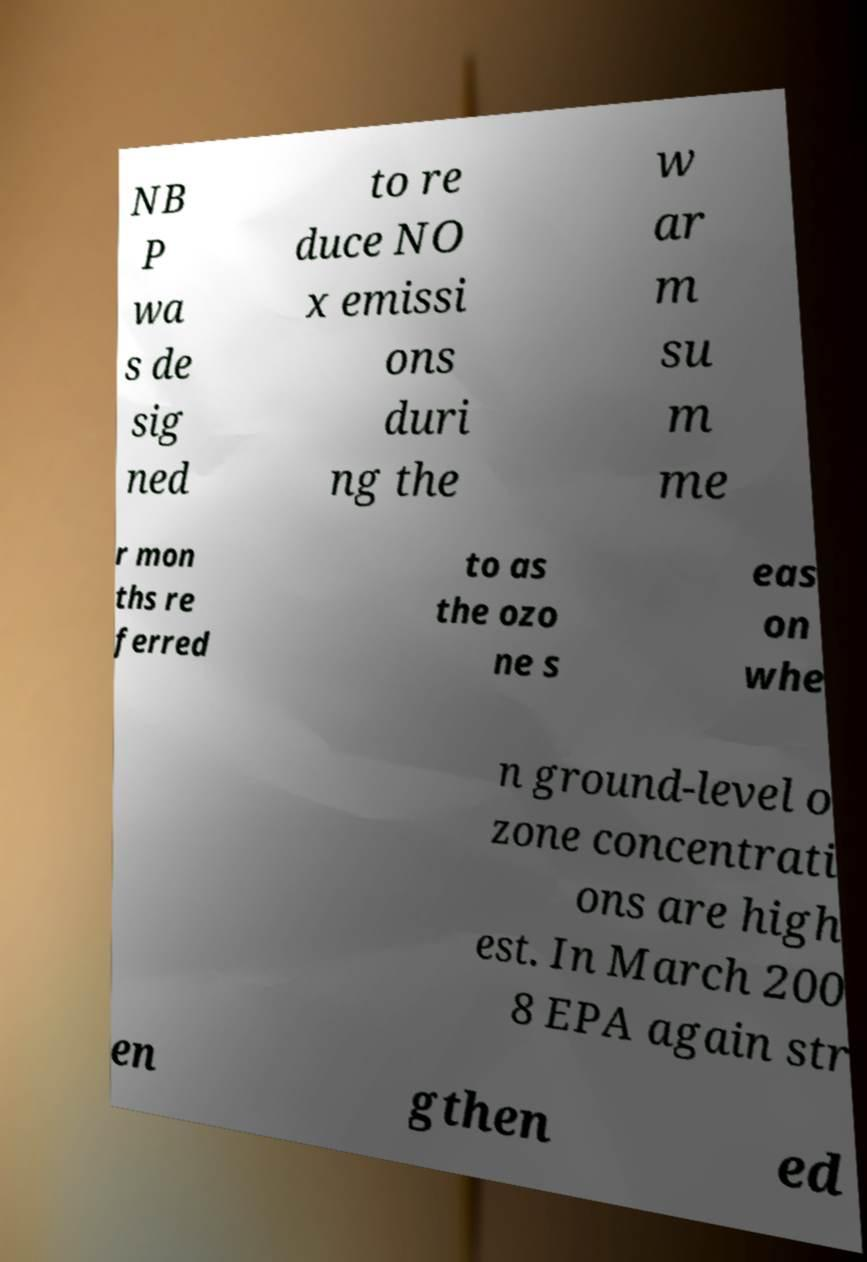Could you extract and type out the text from this image? NB P wa s de sig ned to re duce NO x emissi ons duri ng the w ar m su m me r mon ths re ferred to as the ozo ne s eas on whe n ground-level o zone concentrati ons are high est. In March 200 8 EPA again str en gthen ed 